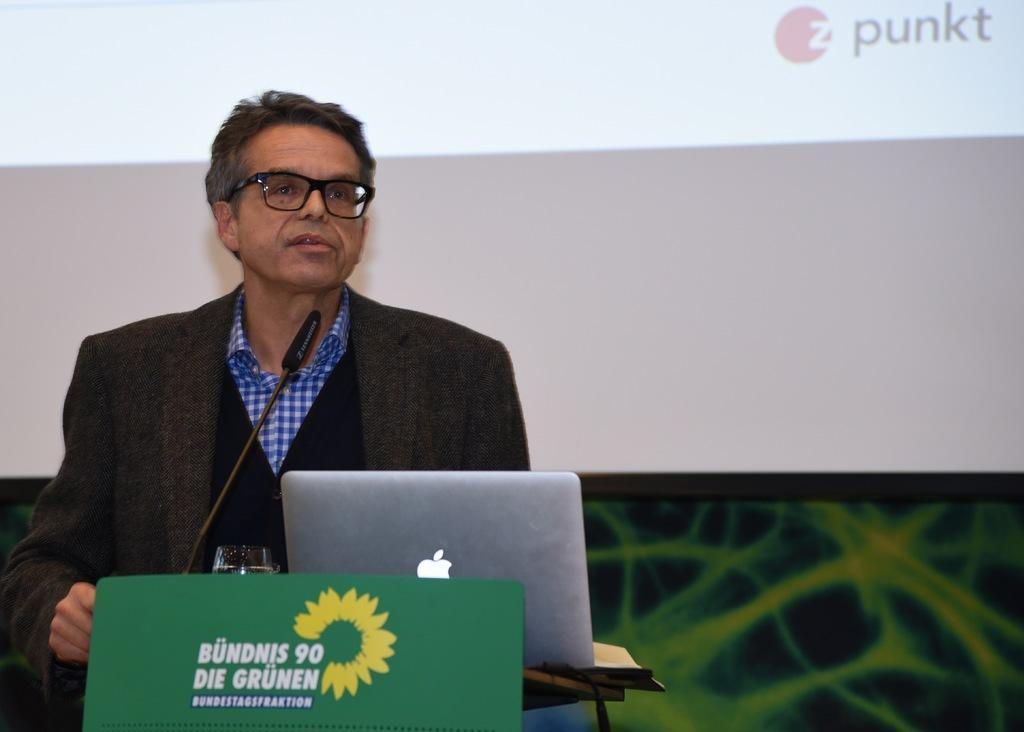How would you summarize this image in a sentence or two? In this image we can see person standing at a desk. On the desk there is a laptop, tumbler and mic. In the background there is a screen and wall. 